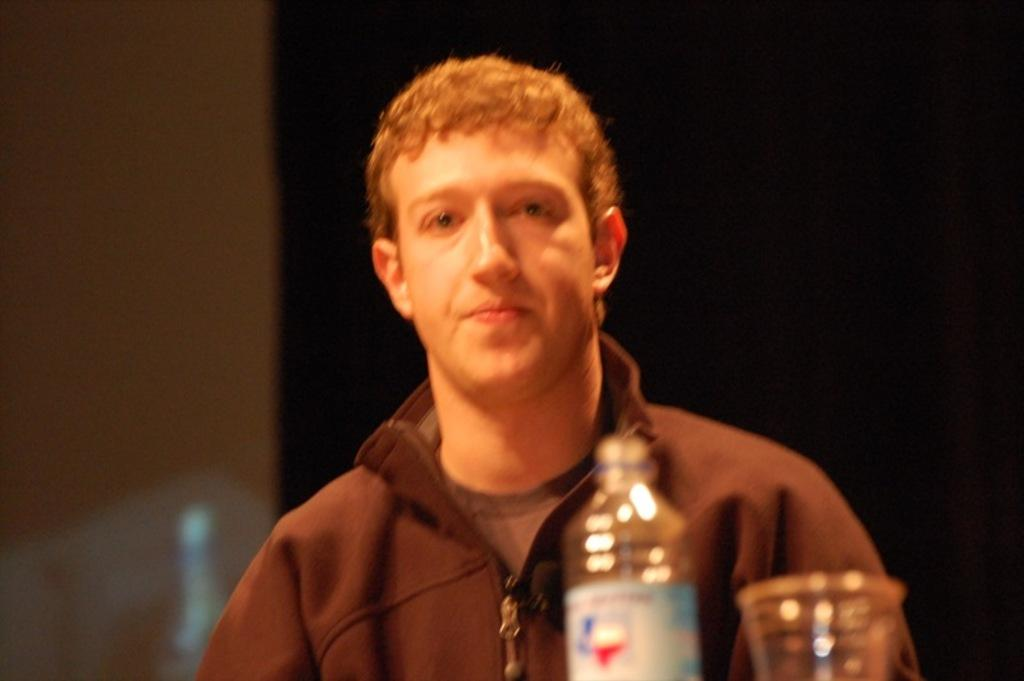Who or what is the main subject of the image? There is a person in the image. What is the person wearing? The person is wearing a jacket. What other objects can be seen in the image? There is a bottle and a cup in the image. What is the color of the background in the image? The background of the image is black. How many cherries are on the person's head in the image? There are no cherries present in the image. What type of polish is the person using on their nails in the image? There is no indication of nail polish or any other personal grooming activity in the image. 